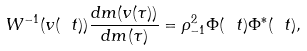<formula> <loc_0><loc_0><loc_500><loc_500>W ^ { - 1 } ( v ( \ t ) ) \frac { d m ( v ( \tau ) ) } { d m ( \tau ) } = \rho _ { - 1 } ^ { 2 } \Phi ( \ t ) \Phi ^ { * } ( \ t ) ,</formula> 